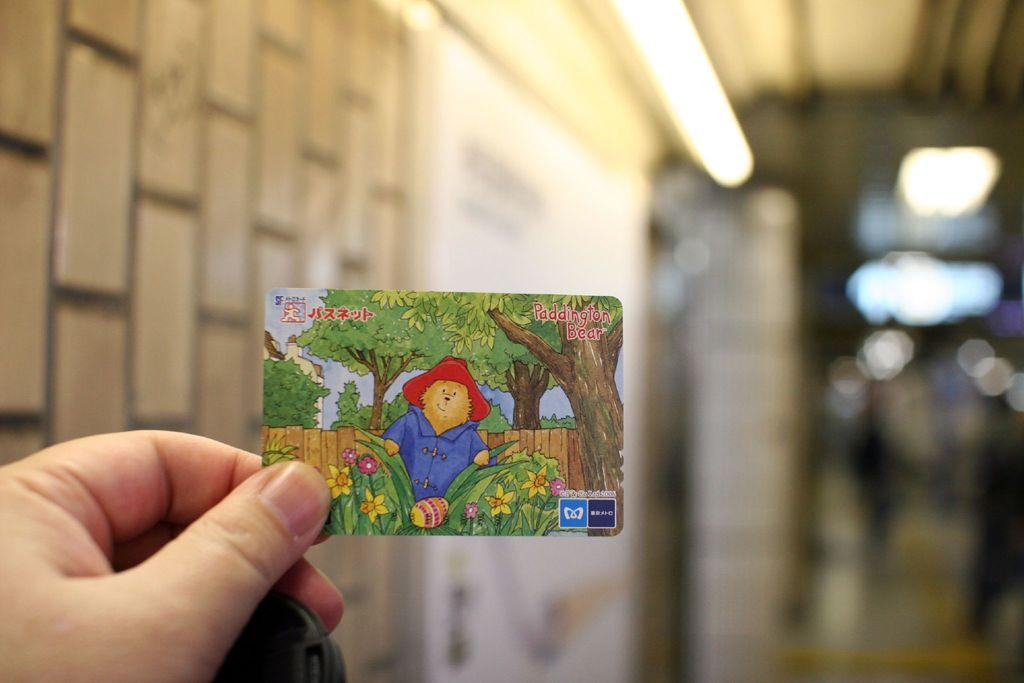What is the main subject of the image? The main subject of the image is a hand holding a card. Can you describe the background of the image? The background of the image is blurred. What type of clouds can be seen in the downtown area in the image? There is no downtown area or clouds present in the image; it only features a hand holding a card with a blurred background. 